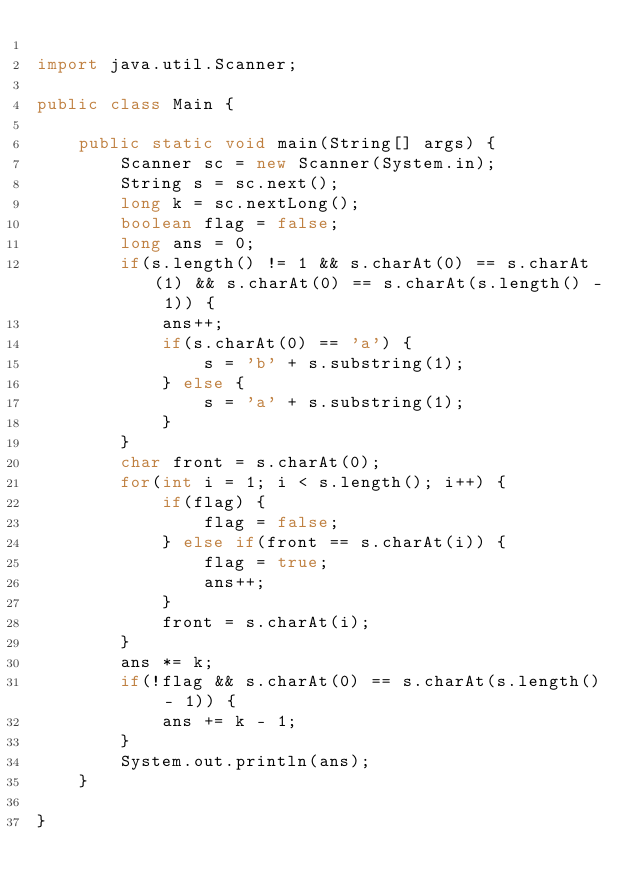Convert code to text. <code><loc_0><loc_0><loc_500><loc_500><_Java_>
import java.util.Scanner;

public class Main {

	public static void main(String[] args) {
		Scanner sc = new Scanner(System.in);
		String s = sc.next();
		long k = sc.nextLong();
		boolean flag = false;
		long ans = 0;
		if(s.length() != 1 && s.charAt(0) == s.charAt(1) && s.charAt(0) == s.charAt(s.length() - 1)) {
			ans++;
			if(s.charAt(0) == 'a') {
				s = 'b' + s.substring(1);
			} else {
				s = 'a' + s.substring(1);
			}
		}
		char front = s.charAt(0);
		for(int i = 1; i < s.length(); i++) {
			if(flag) {
				flag = false;
			} else if(front == s.charAt(i)) {
				flag = true;
				ans++;
			}
			front = s.charAt(i);
		}
		ans *= k;
		if(!flag && s.charAt(0) == s.charAt(s.length() - 1)) {
			ans += k - 1;
		}
		System.out.println(ans);
	}

}
</code> 